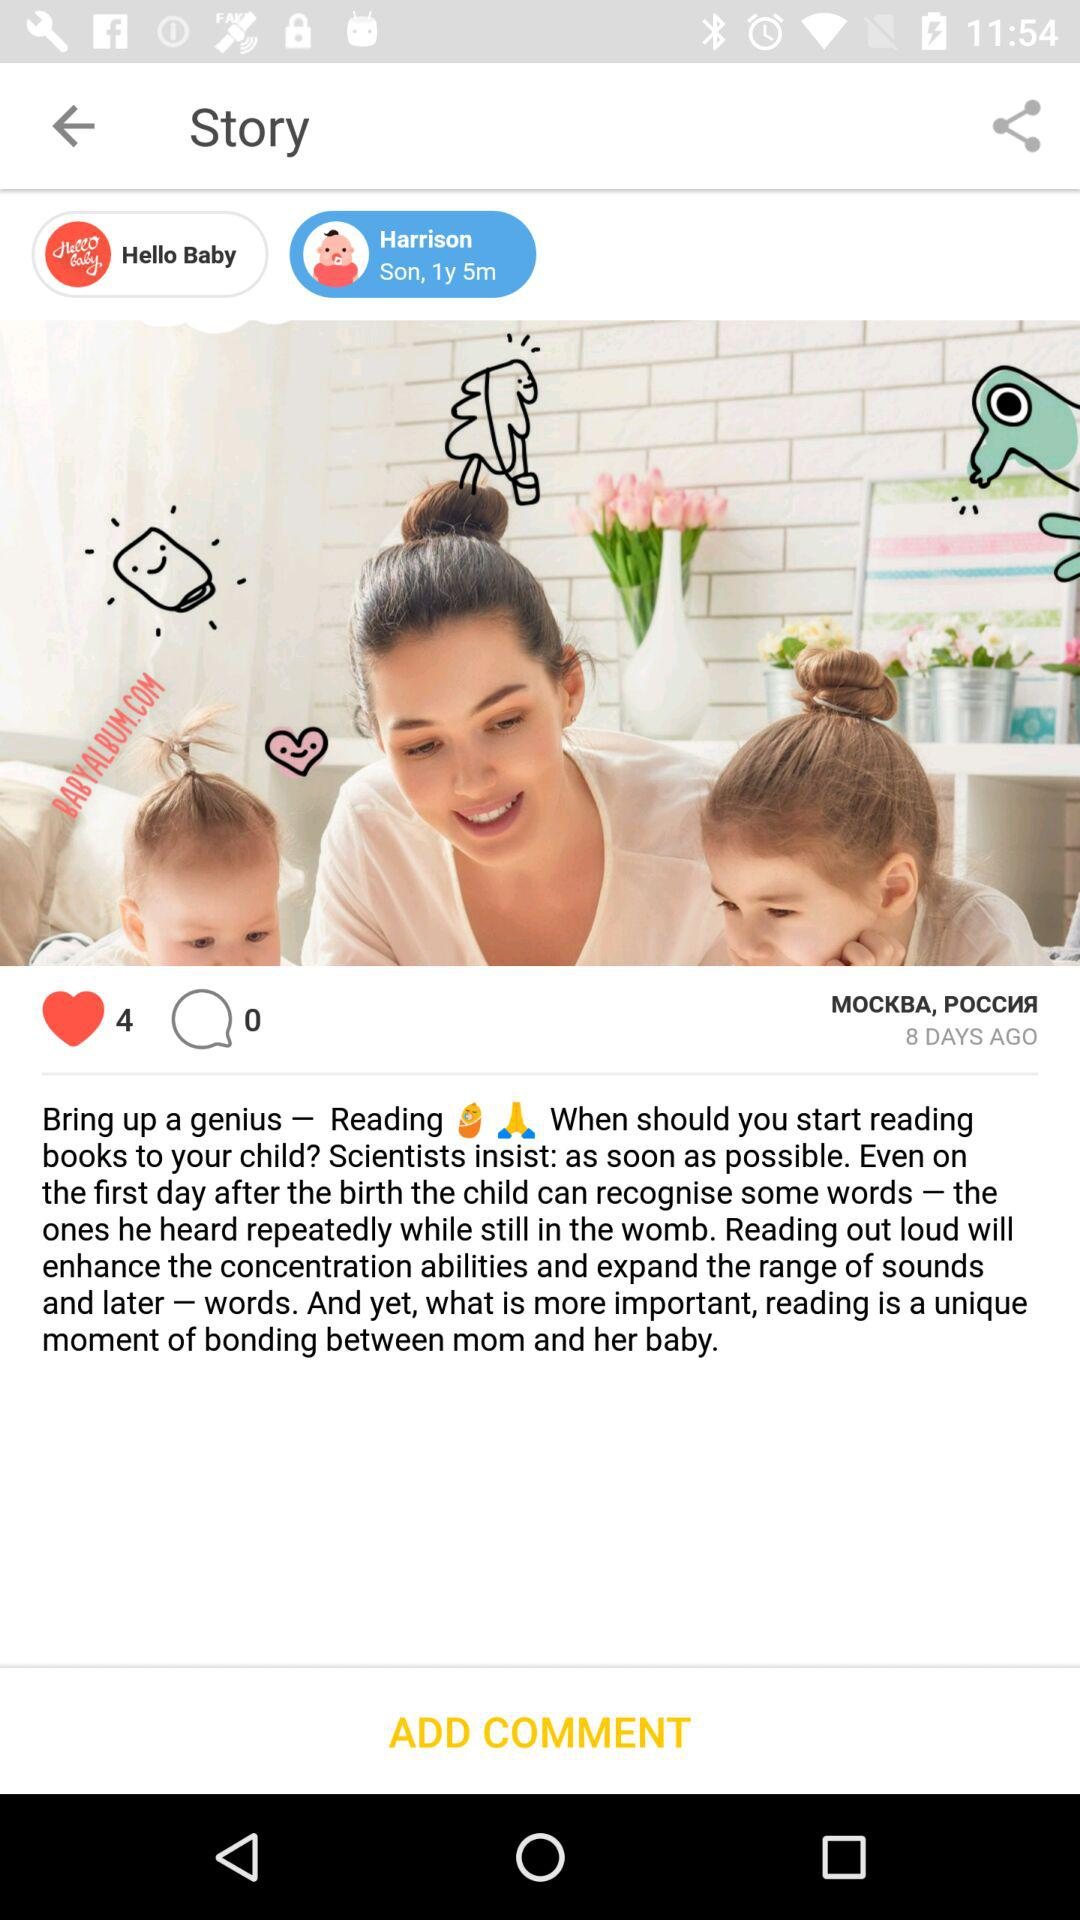What is the number of comments? The number of comments is 0. 